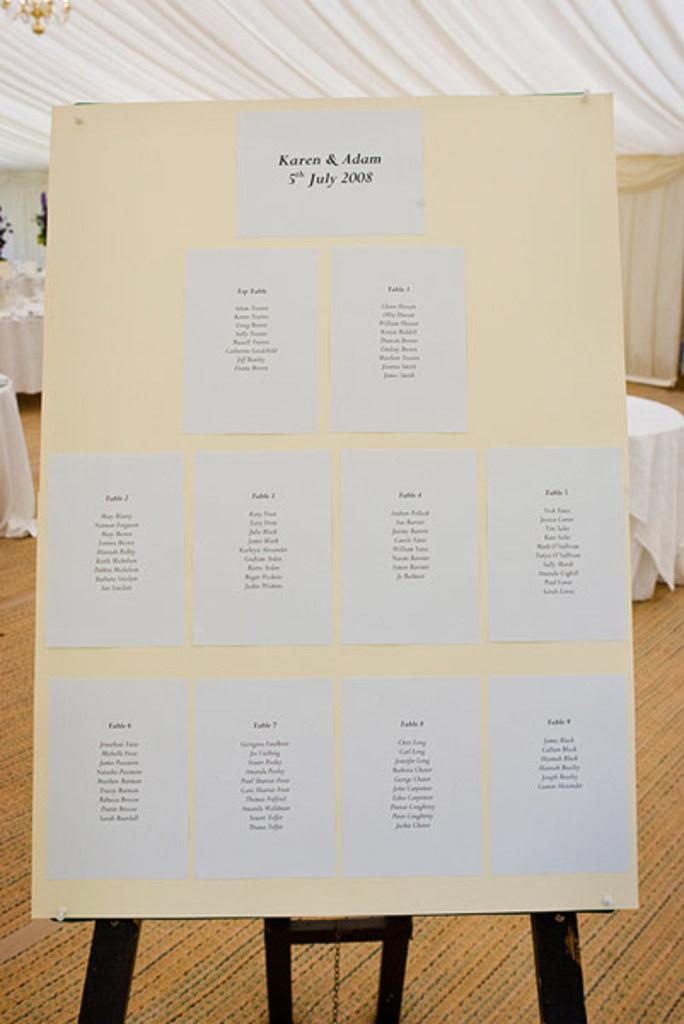What is attached to the board in the image? There are posters on the board in the image. What type of furniture can be seen in the background of the image? There are tables in the background of the image. What type of window treatment is present in the background of the image? There are curtains in the background of the image. What else can be seen in the background of the image? There are some objects visible in the background of the image. Can you hear the whistle of the animals in the zoo in the image? There is no zoo or animals present in the image, so there is no whistle to hear. 